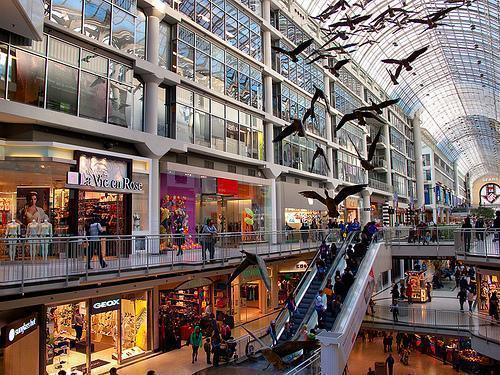What is this type of building called?
Indicate the correct response by choosing from the four available options to answer the question.
Options: Library, mall, supermarket, deli. Mall. 